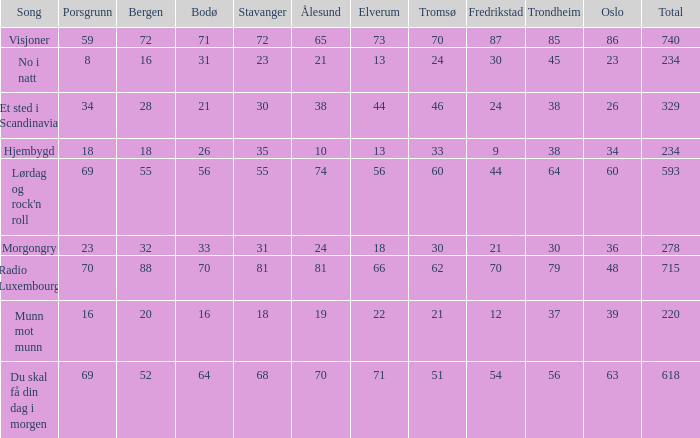What was the complete total for radio luxembourg? 715.0. 